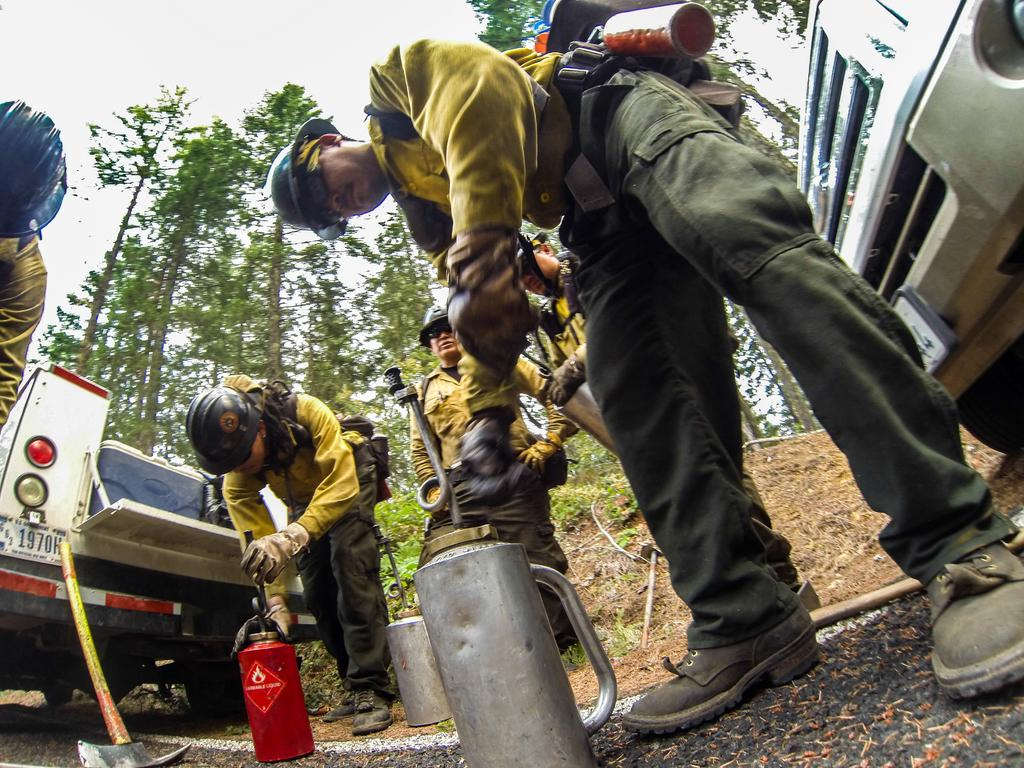Who or what can be seen in the image? There are people in the image. What objects are present on the road? There are cylinders on the road. What types of transportation are in the image? There are vehicles in the image. What item can be seen that is typically used for a specific task? There is a tool visible in the image. What natural elements can be seen in the background of the image? There are trees and the sky visible in the background of the image. What type of crown is being worn by the trees in the background of the image? There are no crowns present in the image, as the trees are not wearing any accessories. 